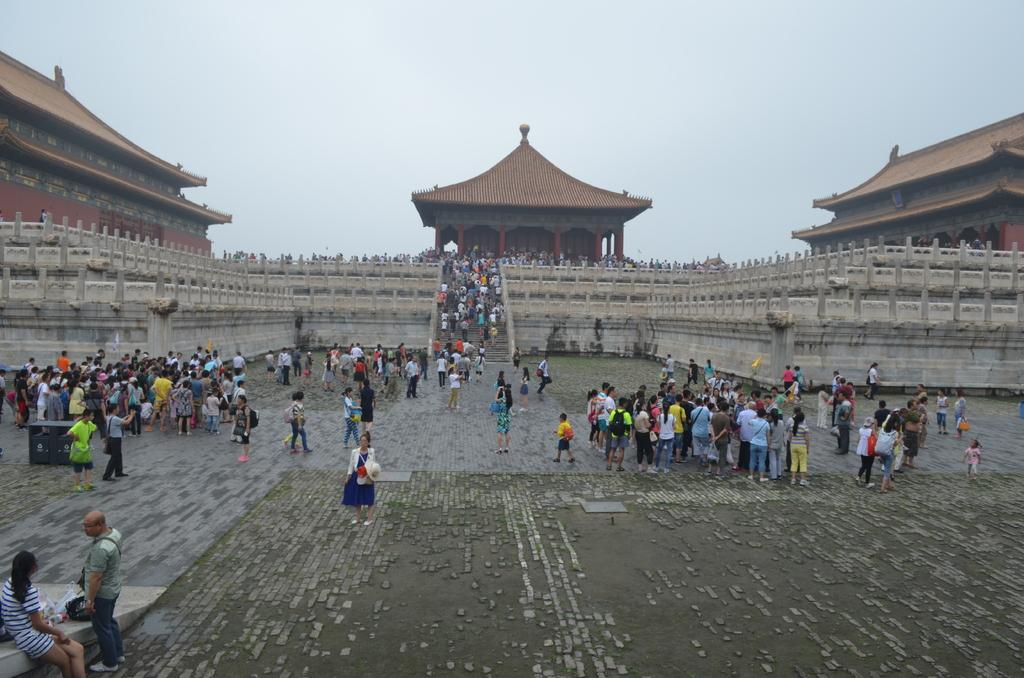What is happening in the image? There is a group of people standing in the image. What can be seen in the distance behind the people? There are buildings in the background of the image. What is visible above the buildings? The sky is visible in the background of the image. What type of cough is the toad experiencing in the image? There is no toad or cough present in the image. How many apples are being held by the people in the image? There is no mention of apples in the image, so we cannot determine how many are being held. 